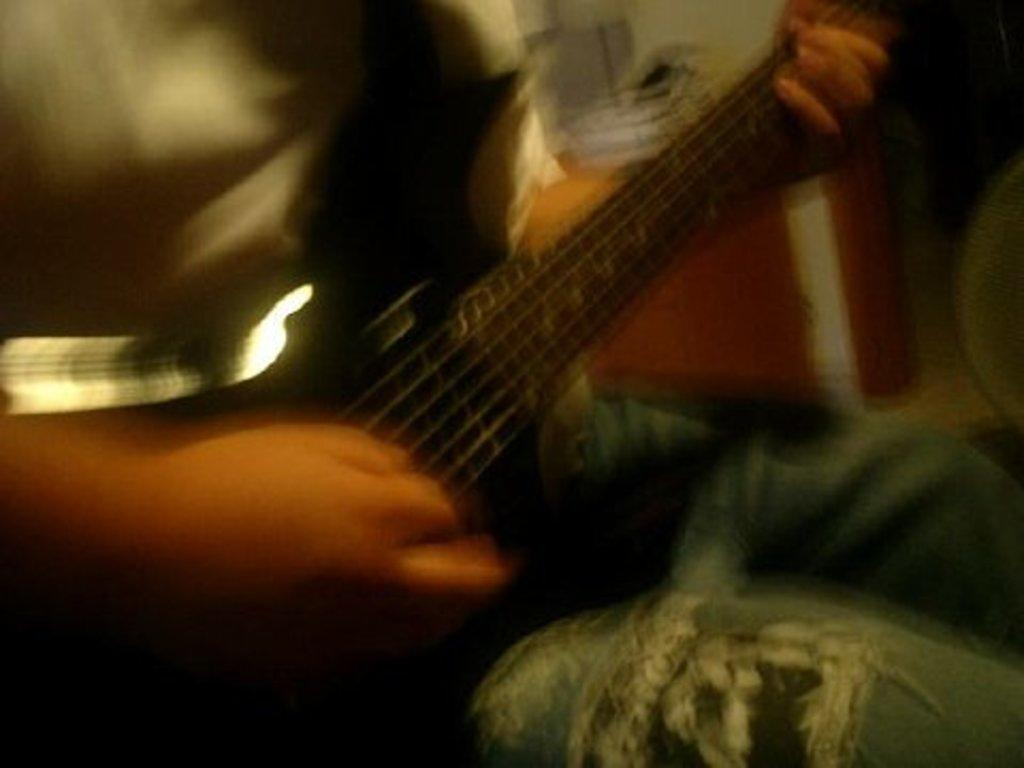What is the main subject of the image? There is a person in the image. What is the person holding in the image? The person is holding a guitar. What position is the person in? The person is sitting. Can you describe the background of the image? The background of the image is blurry. What type of fruit is the person using as a scale in the image? There is no fruit or scale present in the image. Is the person in the image asking for money from passersby? There is no indication in the image that the person is a beggar or asking for money. 